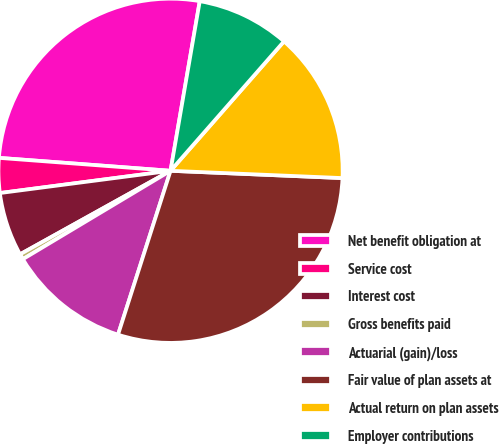Convert chart. <chart><loc_0><loc_0><loc_500><loc_500><pie_chart><fcel>Net benefit obligation at<fcel>Service cost<fcel>Interest cost<fcel>Gross benefits paid<fcel>Actuarial (gain)/loss<fcel>Fair value of plan assets at<fcel>Actual return on plan assets<fcel>Employer contributions<nl><fcel>26.52%<fcel>3.26%<fcel>6.0%<fcel>0.52%<fcel>11.48%<fcel>29.26%<fcel>14.22%<fcel>8.74%<nl></chart> 